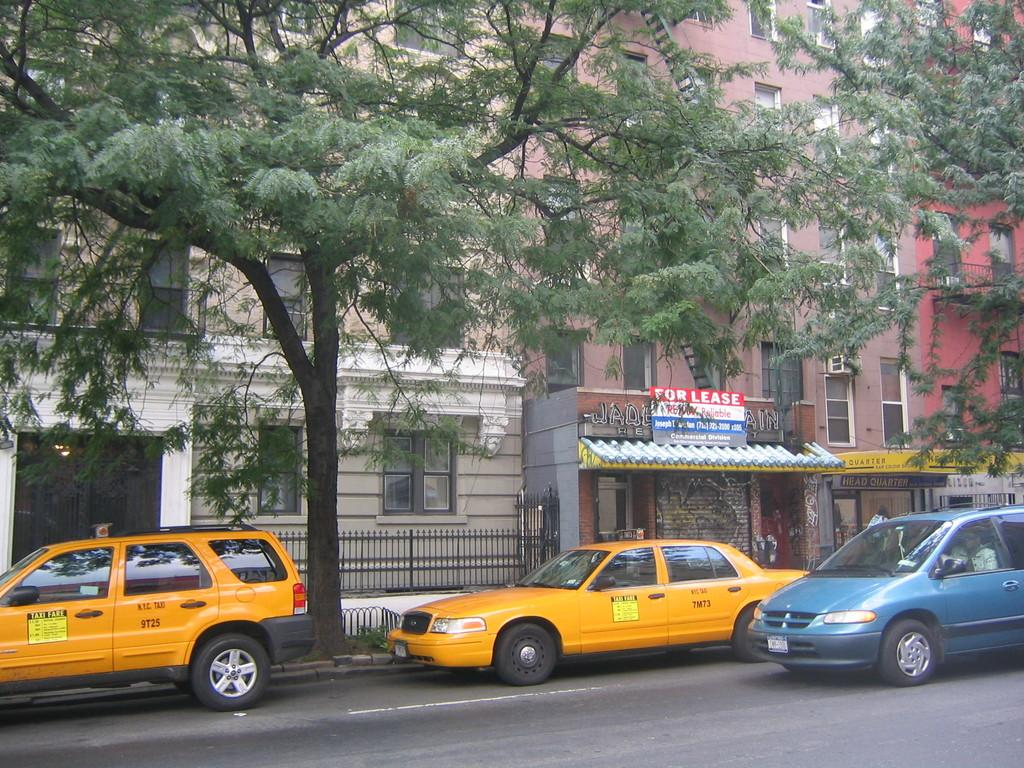Provide a one-sentence caption for the provided image. A "FOR LEASE" sign is above a taxi. 